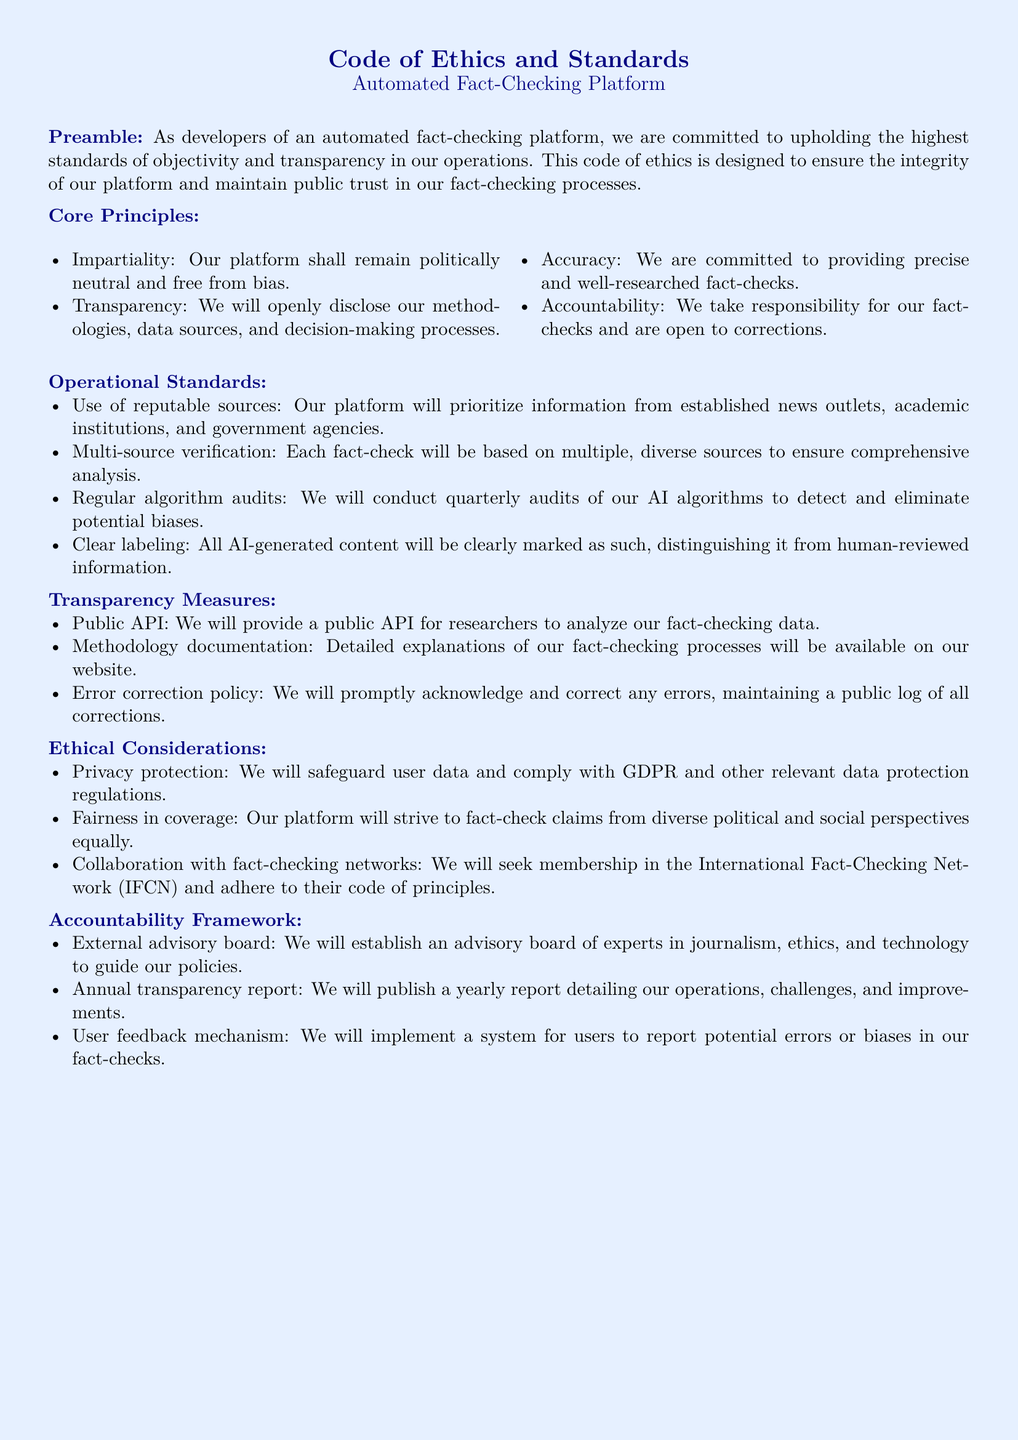What are the core principles? The core principles listed in the document include impartiality, transparency, accuracy, and accountability.
Answer: Impartiality, transparency, accuracy, accountability How often will algorithm audits be conducted? The document states that quarterly audits will be conducted to detect and eliminate potential biases in AI algorithms.
Answer: Quarterly What kind of sources will the platform prioritize? The platform will prioritize information from reputable sources such as established news outlets, academic institutions, and government agencies.
Answer: Reputable sources What will the advisory board consist of? The external advisory board will consist of experts in journalism, ethics, and technology.
Answer: Experts in journalism, ethics, and technology Which networks will the platform seek membership in? The platform will seek membership in the International Fact-Checking Network (IFCN).
Answer: International Fact-Checking Network (IFCN) What will be detailed in the annual transparency report? The annual transparency report will detail operations, challenges, and improvements in the fact-checking platform.
Answer: Operations, challenges, and improvements What is the purpose of the public API? The public API is intended for researchers to analyze the fact-checking data of the platform.
Answer: Analyze fact-checking data What is the policy for error correction? The document states that the platform will promptly acknowledge and correct any errors and maintain a public log of all corrections.
Answer: Public log of all corrections 